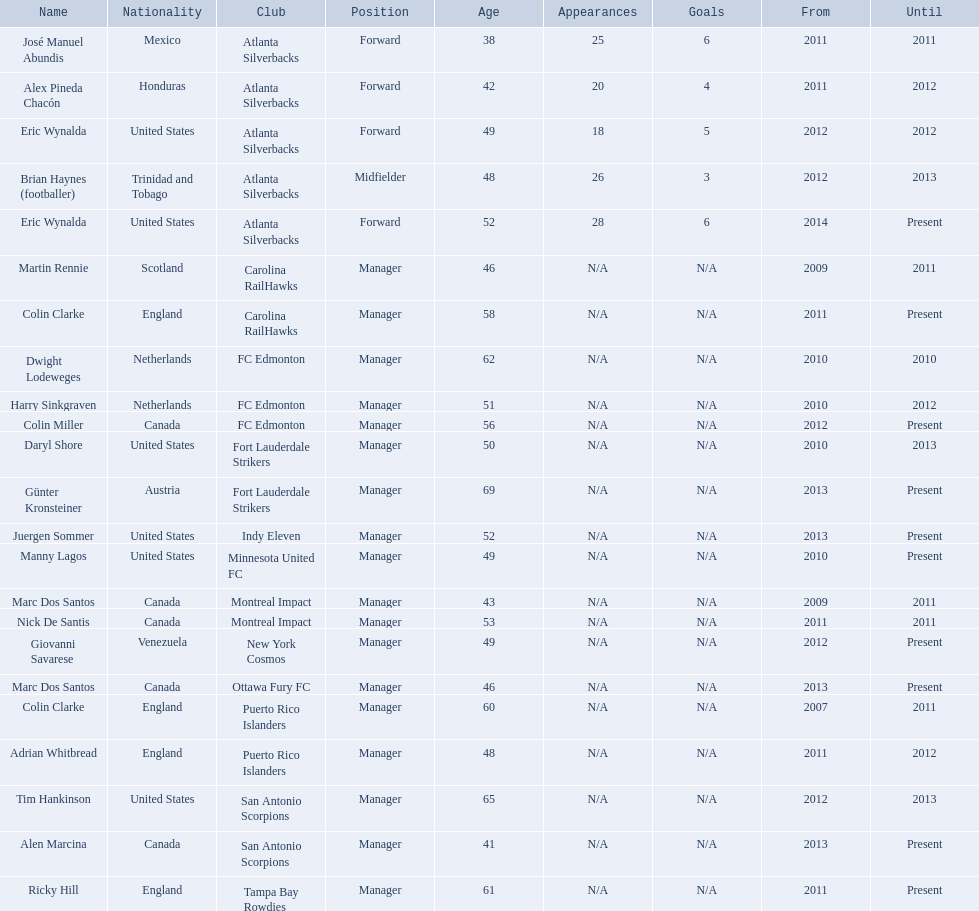What were all the coaches who were coaching in 2010? Martin Rennie, Dwight Lodeweges, Harry Sinkgraven, Daryl Shore, Manny Lagos, Marc Dos Santos, Colin Clarke. Which of the 2010 coaches were not born in north america? Martin Rennie, Dwight Lodeweges, Harry Sinkgraven, Colin Clarke. Which coaches that were coaching in 2010 and were not from north america did not coach for fc edmonton? Martin Rennie, Colin Clarke. What coach did not coach for fc edmonton in 2010 and was not north american nationality had the shortened career as a coach? Martin Rennie. 